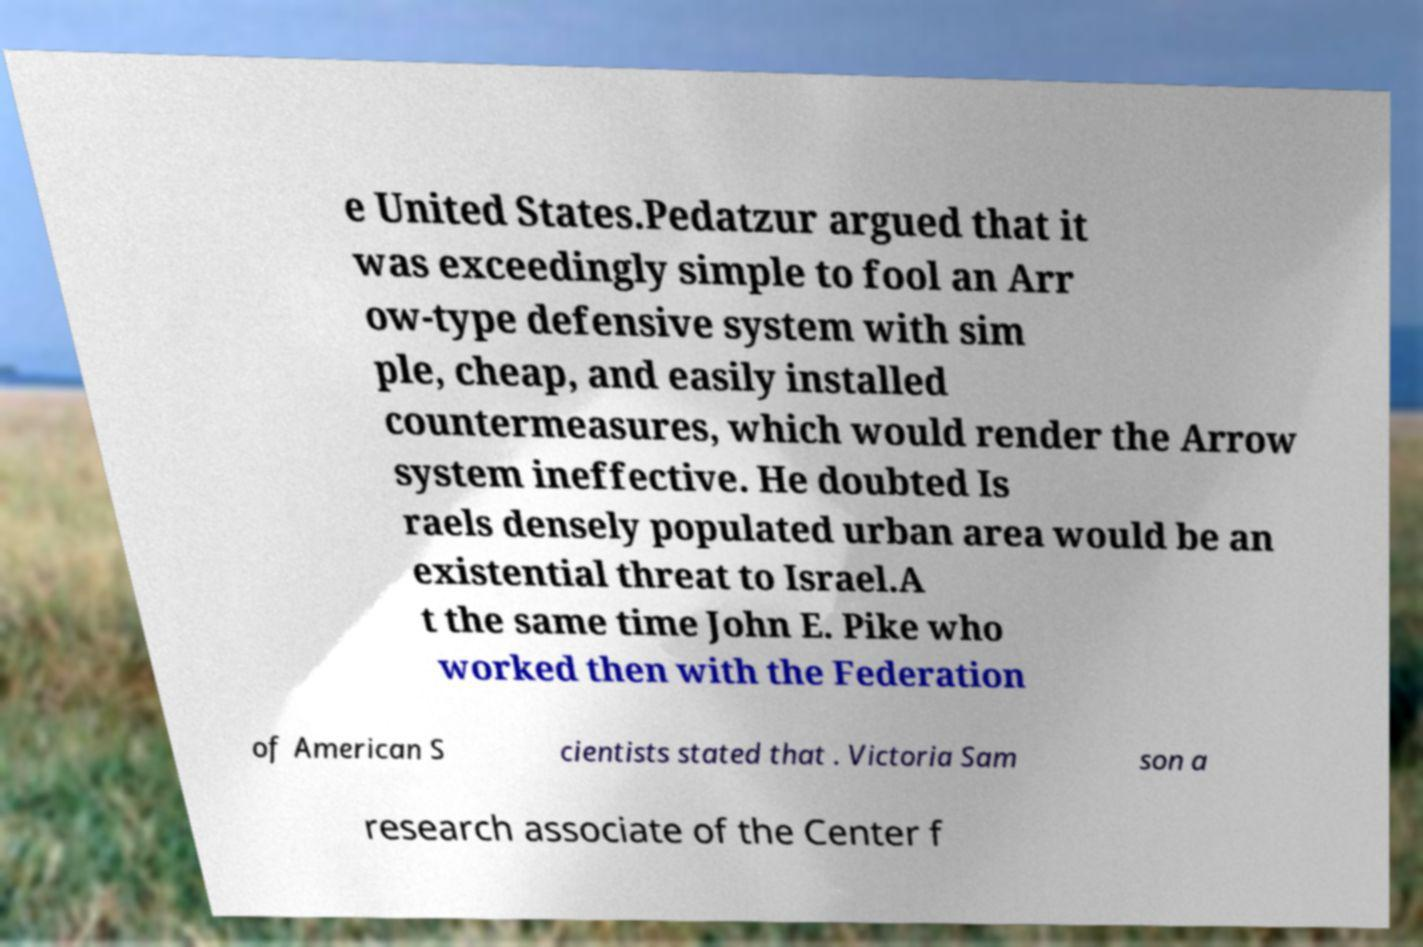For documentation purposes, I need the text within this image transcribed. Could you provide that? e United States.Pedatzur argued that it was exceedingly simple to fool an Arr ow-type defensive system with sim ple, cheap, and easily installed countermeasures, which would render the Arrow system ineffective. He doubted Is raels densely populated urban area would be an existential threat to Israel.A t the same time John E. Pike who worked then with the Federation of American S cientists stated that . Victoria Sam son a research associate of the Center f 